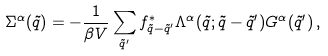<formula> <loc_0><loc_0><loc_500><loc_500>\Sigma ^ { \alpha } ( \tilde { q } ) = - \frac { 1 } { \beta V } \sum _ { \tilde { q } ^ { \prime } } f ^ { \ast } _ { \tilde { q } - \tilde { q } ^ { \prime } } \Lambda ^ { \alpha } ( { \tilde { q } ; \tilde { q } - \tilde { q } ^ { \prime } } ) G ^ { \alpha } ( \tilde { q } ^ { \prime } ) \, ,</formula> 